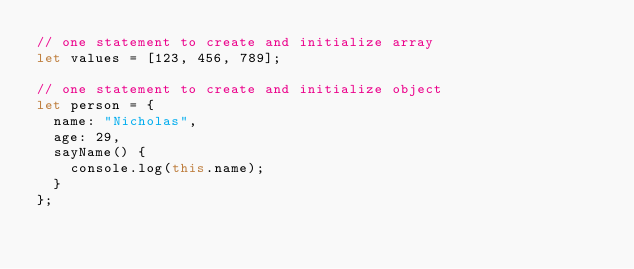Convert code to text. <code><loc_0><loc_0><loc_500><loc_500><_JavaScript_>// one statement to create and initialize array
let values = [123, 456, 789];
           
// one statement to create and initialize object
let person = {
  name: "Nicholas",
  age: 29,
  sayName() {
    console.log(this.name);
  }
};
</code> 